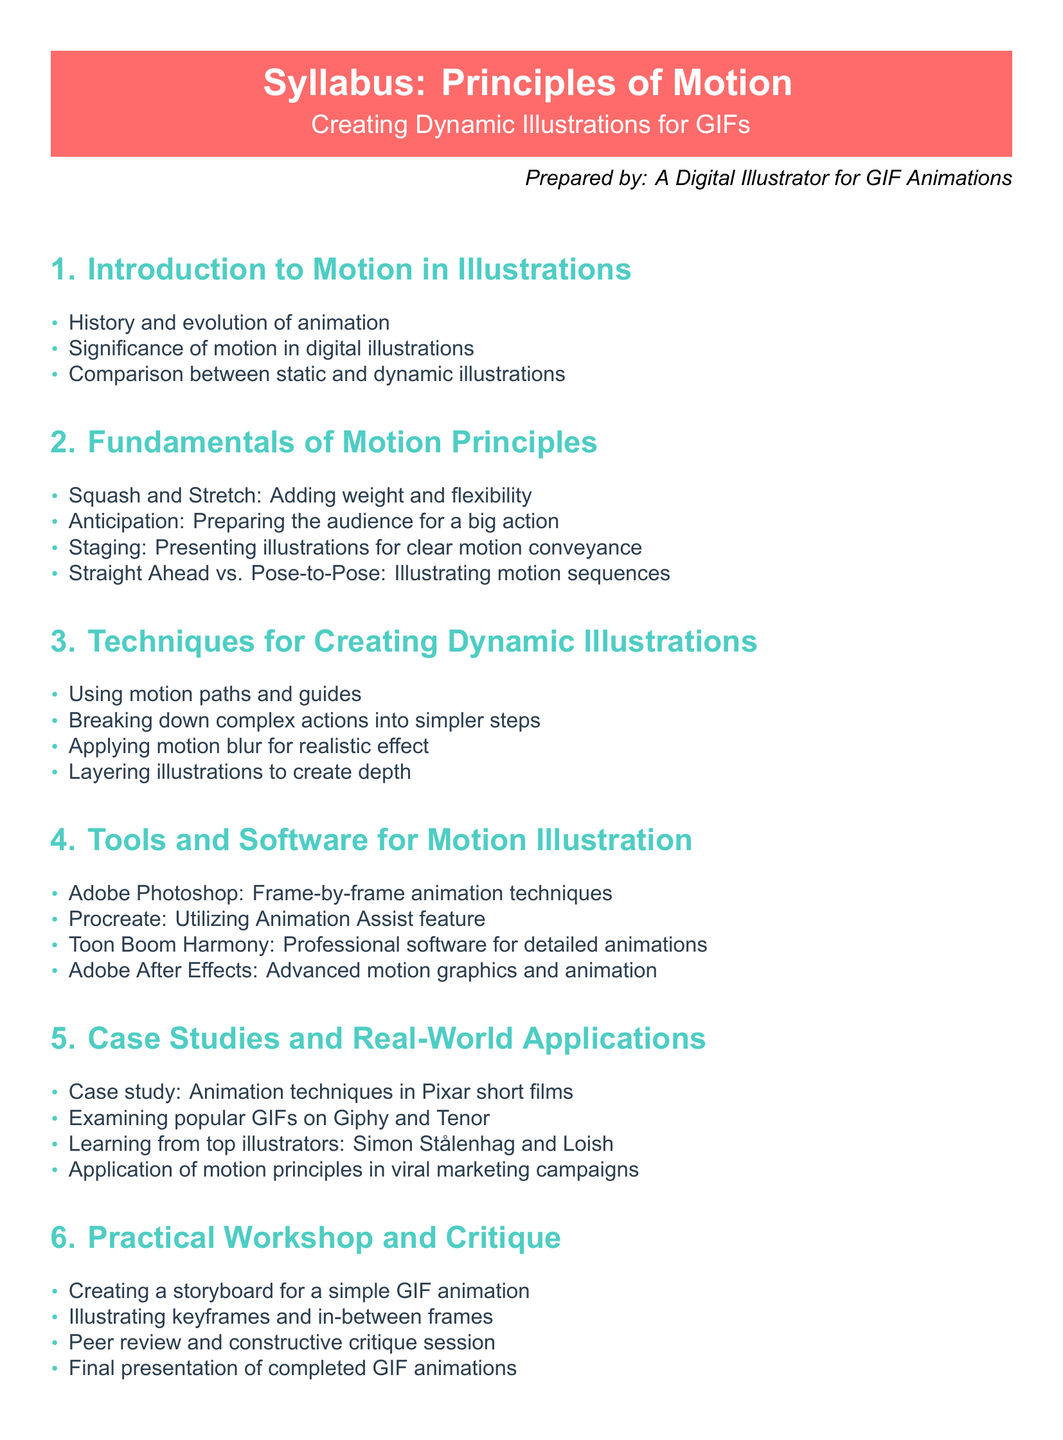What is the title of the syllabus? The title of the syllabus is prominently displayed at the beginning of the document.
Answer: Principles of Motion Who prepared the syllabus? The document includes a note indicating who prepared it in the footer.
Answer: A Digital Illustrator for GIF Animations How many main sections are in the syllabus? The document lists six main sections, which can be counted.
Answer: 6 What principle involves preparing the audience for a big action? This principle is mentioned in the Fundamentals of Motion Principles section.
Answer: Anticipation Which software is associated with frame-by-frame animation techniques? The document lists specific software under the Tools and Software for Motion Illustration section.
Answer: Adobe Photoshop What is the first topic under Techniques for Creating Dynamic Illustrations? The document provides a list of topics, and the first one can be found easily.
Answer: Using motion paths and guides What is the focus of the Practical Workshop and Critique section? The section describes various activities related to GIF animation creation and presentation.
Answer: Creating a storyboard for a simple GIF animation Name one illustrator mentioned in the Case Studies section. The document lists examples of illustrators to learn from in real-world applications.
Answer: Simon Stålenhag What does the term "Squash and Stretch" refer to? This term is used in the context of adding weight and flexibility to illustrations in the Principles section.
Answer: Adding weight and flexibility 